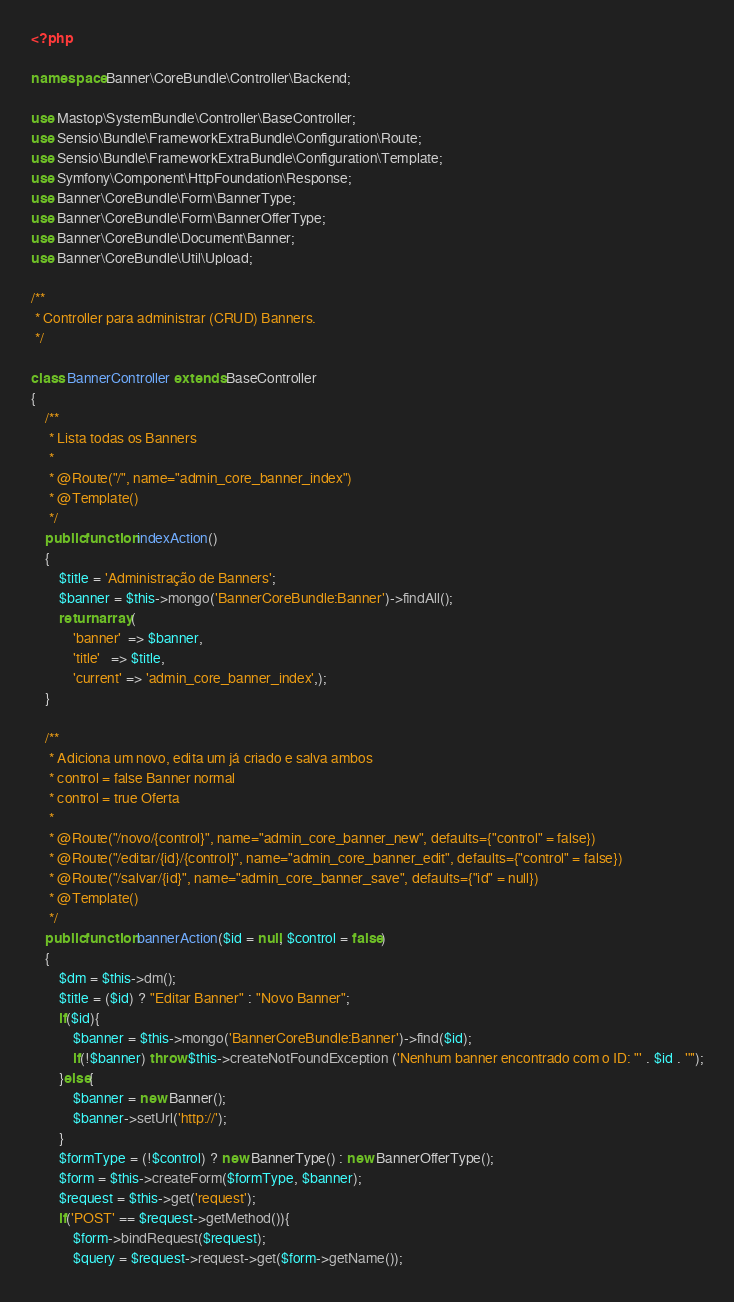Convert code to text. <code><loc_0><loc_0><loc_500><loc_500><_PHP_><?php

namespace Banner\CoreBundle\Controller\Backend;

use Mastop\SystemBundle\Controller\BaseController;
use Sensio\Bundle\FrameworkExtraBundle\Configuration\Route;
use Sensio\Bundle\FrameworkExtraBundle\Configuration\Template;
use Symfony\Component\HttpFoundation\Response;
use Banner\CoreBundle\Form\BannerType;
use Banner\CoreBundle\Form\BannerOfferType;
use Banner\CoreBundle\Document\Banner;
use Banner\CoreBundle\Util\Upload;

/**
 * Controller para administrar (CRUD) Banners.
 */

class BannerController extends BaseController
{
    /**
     * Lista todas os Banners
     * 
     * @Route("/", name="admin_core_banner_index")
     * @Template()
     */
    public function indexAction()
    {
        $title = 'Administração de Banners';
        $banner = $this->mongo('BannerCoreBundle:Banner')->findAll();
        return array(
            'banner'  => $banner,
            'title'   => $title,
            'current' => 'admin_core_banner_index',);
    }
    
    /**
     * Adiciona um novo, edita um já criado e salva ambos
     * control = false Banner normal
     * control = true Oferta
     * 
     * @Route("/novo/{control}", name="admin_core_banner_new", defaults={"control" = false})
     * @Route("/editar/{id}/{control}", name="admin_core_banner_edit", defaults={"control" = false})
     * @Route("/salvar/{id}", name="admin_core_banner_save", defaults={"id" = null})
     * @Template()
     */
    public function bannerAction($id = null, $control = false)
    {
        $dm = $this->dm();
        $title = ($id) ? "Editar Banner" : "Novo Banner";
        if($id){
            $banner = $this->mongo('BannerCoreBundle:Banner')->find($id);
            if(!$banner) throw $this->createNotFoundException ('Nenhum banner encontrado com o ID: "' . $id . '"');
        }else{
            $banner = new Banner();
            $banner->setUrl('http://');
        }
        $formType = (!$control) ? new BannerType() : new BannerOfferType();
        $form = $this->createForm($formType, $banner);
        $request = $this->get('request');
        if('POST' == $request->getMethod()){
            $form->bindRequest($request);
            $query = $request->request->get($form->getName());</code> 